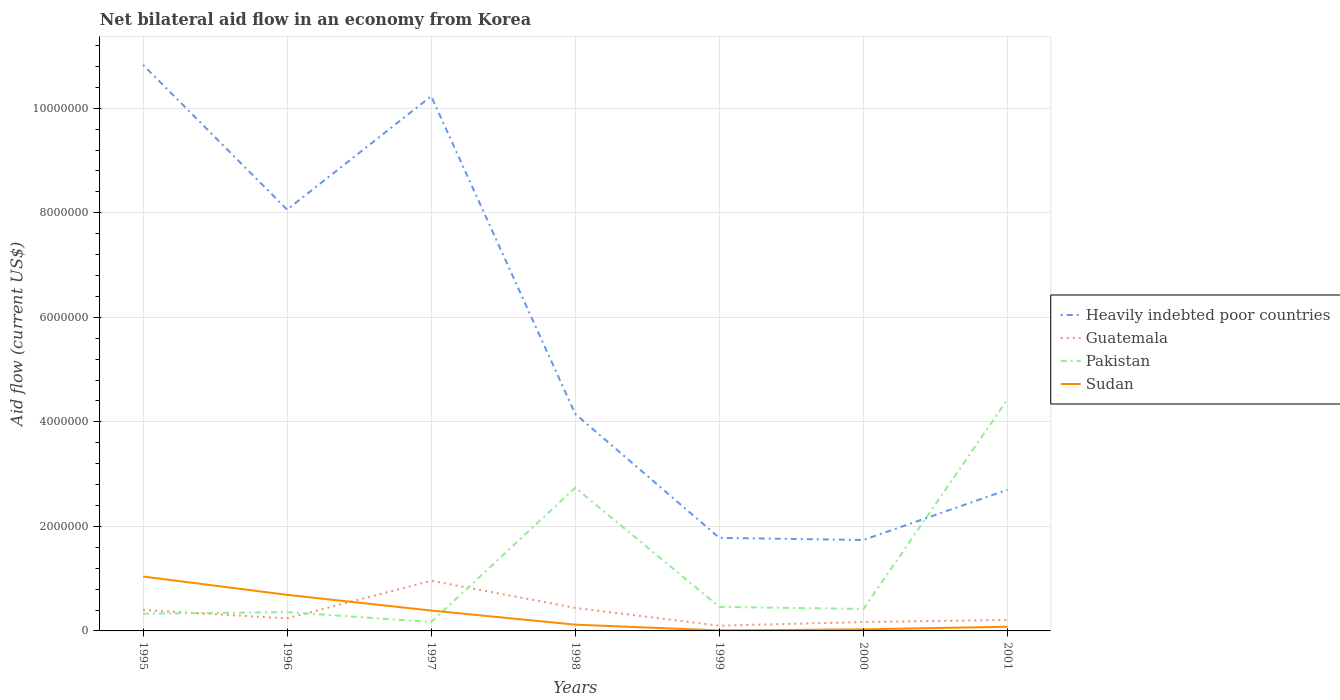How many different coloured lines are there?
Give a very brief answer. 4. Does the line corresponding to Guatemala intersect with the line corresponding to Sudan?
Ensure brevity in your answer.  Yes. What is the total net bilateral aid flow in Sudan in the graph?
Make the answer very short. 6.60e+05. What is the difference between the highest and the second highest net bilateral aid flow in Heavily indebted poor countries?
Your answer should be very brief. 9.09e+06. Is the net bilateral aid flow in Heavily indebted poor countries strictly greater than the net bilateral aid flow in Pakistan over the years?
Provide a short and direct response. No. How many lines are there?
Provide a short and direct response. 4. How many years are there in the graph?
Provide a short and direct response. 7. Are the values on the major ticks of Y-axis written in scientific E-notation?
Your answer should be very brief. No. Does the graph contain any zero values?
Your answer should be very brief. No. Where does the legend appear in the graph?
Your answer should be compact. Center right. How are the legend labels stacked?
Make the answer very short. Vertical. What is the title of the graph?
Keep it short and to the point. Net bilateral aid flow in an economy from Korea. What is the Aid flow (current US$) in Heavily indebted poor countries in 1995?
Ensure brevity in your answer.  1.08e+07. What is the Aid flow (current US$) of Sudan in 1995?
Make the answer very short. 1.04e+06. What is the Aid flow (current US$) in Heavily indebted poor countries in 1996?
Keep it short and to the point. 8.06e+06. What is the Aid flow (current US$) in Guatemala in 1996?
Give a very brief answer. 2.40e+05. What is the Aid flow (current US$) in Sudan in 1996?
Your answer should be very brief. 6.90e+05. What is the Aid flow (current US$) in Heavily indebted poor countries in 1997?
Your answer should be very brief. 1.02e+07. What is the Aid flow (current US$) in Guatemala in 1997?
Your answer should be very brief. 9.60e+05. What is the Aid flow (current US$) in Sudan in 1997?
Your answer should be very brief. 3.90e+05. What is the Aid flow (current US$) in Heavily indebted poor countries in 1998?
Make the answer very short. 4.15e+06. What is the Aid flow (current US$) of Guatemala in 1998?
Make the answer very short. 4.40e+05. What is the Aid flow (current US$) in Pakistan in 1998?
Your answer should be very brief. 2.74e+06. What is the Aid flow (current US$) of Sudan in 1998?
Provide a short and direct response. 1.20e+05. What is the Aid flow (current US$) in Heavily indebted poor countries in 1999?
Your response must be concise. 1.78e+06. What is the Aid flow (current US$) of Guatemala in 1999?
Your response must be concise. 1.00e+05. What is the Aid flow (current US$) of Sudan in 1999?
Your answer should be compact. 10000. What is the Aid flow (current US$) of Heavily indebted poor countries in 2000?
Provide a succinct answer. 1.74e+06. What is the Aid flow (current US$) of Guatemala in 2000?
Your response must be concise. 1.70e+05. What is the Aid flow (current US$) in Pakistan in 2000?
Provide a succinct answer. 4.20e+05. What is the Aid flow (current US$) of Sudan in 2000?
Your answer should be compact. 3.00e+04. What is the Aid flow (current US$) of Heavily indebted poor countries in 2001?
Provide a succinct answer. 2.70e+06. What is the Aid flow (current US$) of Pakistan in 2001?
Provide a short and direct response. 4.43e+06. Across all years, what is the maximum Aid flow (current US$) of Heavily indebted poor countries?
Give a very brief answer. 1.08e+07. Across all years, what is the maximum Aid flow (current US$) of Guatemala?
Your answer should be compact. 9.60e+05. Across all years, what is the maximum Aid flow (current US$) in Pakistan?
Make the answer very short. 4.43e+06. Across all years, what is the maximum Aid flow (current US$) in Sudan?
Ensure brevity in your answer.  1.04e+06. Across all years, what is the minimum Aid flow (current US$) in Heavily indebted poor countries?
Provide a short and direct response. 1.74e+06. Across all years, what is the minimum Aid flow (current US$) of Pakistan?
Your response must be concise. 1.70e+05. Across all years, what is the minimum Aid flow (current US$) in Sudan?
Your answer should be very brief. 10000. What is the total Aid flow (current US$) of Heavily indebted poor countries in the graph?
Give a very brief answer. 3.95e+07. What is the total Aid flow (current US$) of Guatemala in the graph?
Keep it short and to the point. 2.52e+06. What is the total Aid flow (current US$) of Pakistan in the graph?
Your response must be concise. 8.91e+06. What is the total Aid flow (current US$) of Sudan in the graph?
Provide a short and direct response. 2.36e+06. What is the difference between the Aid flow (current US$) in Heavily indebted poor countries in 1995 and that in 1996?
Provide a succinct answer. 2.77e+06. What is the difference between the Aid flow (current US$) of Guatemala in 1995 and that in 1996?
Offer a terse response. 1.60e+05. What is the difference between the Aid flow (current US$) of Pakistan in 1995 and that in 1996?
Keep it short and to the point. -3.00e+04. What is the difference between the Aid flow (current US$) of Guatemala in 1995 and that in 1997?
Provide a short and direct response. -5.60e+05. What is the difference between the Aid flow (current US$) of Pakistan in 1995 and that in 1997?
Your answer should be compact. 1.60e+05. What is the difference between the Aid flow (current US$) of Sudan in 1995 and that in 1997?
Your response must be concise. 6.50e+05. What is the difference between the Aid flow (current US$) in Heavily indebted poor countries in 1995 and that in 1998?
Your answer should be very brief. 6.68e+06. What is the difference between the Aid flow (current US$) in Pakistan in 1995 and that in 1998?
Provide a succinct answer. -2.41e+06. What is the difference between the Aid flow (current US$) of Sudan in 1995 and that in 1998?
Your response must be concise. 9.20e+05. What is the difference between the Aid flow (current US$) in Heavily indebted poor countries in 1995 and that in 1999?
Offer a very short reply. 9.05e+06. What is the difference between the Aid flow (current US$) of Guatemala in 1995 and that in 1999?
Give a very brief answer. 3.00e+05. What is the difference between the Aid flow (current US$) of Sudan in 1995 and that in 1999?
Your response must be concise. 1.03e+06. What is the difference between the Aid flow (current US$) of Heavily indebted poor countries in 1995 and that in 2000?
Your answer should be very brief. 9.09e+06. What is the difference between the Aid flow (current US$) in Guatemala in 1995 and that in 2000?
Your answer should be very brief. 2.30e+05. What is the difference between the Aid flow (current US$) in Sudan in 1995 and that in 2000?
Ensure brevity in your answer.  1.01e+06. What is the difference between the Aid flow (current US$) in Heavily indebted poor countries in 1995 and that in 2001?
Your response must be concise. 8.13e+06. What is the difference between the Aid flow (current US$) in Pakistan in 1995 and that in 2001?
Keep it short and to the point. -4.10e+06. What is the difference between the Aid flow (current US$) of Sudan in 1995 and that in 2001?
Your response must be concise. 9.60e+05. What is the difference between the Aid flow (current US$) in Heavily indebted poor countries in 1996 and that in 1997?
Your answer should be compact. -2.17e+06. What is the difference between the Aid flow (current US$) of Guatemala in 1996 and that in 1997?
Provide a short and direct response. -7.20e+05. What is the difference between the Aid flow (current US$) in Pakistan in 1996 and that in 1997?
Keep it short and to the point. 1.90e+05. What is the difference between the Aid flow (current US$) of Sudan in 1996 and that in 1997?
Your answer should be very brief. 3.00e+05. What is the difference between the Aid flow (current US$) of Heavily indebted poor countries in 1996 and that in 1998?
Give a very brief answer. 3.91e+06. What is the difference between the Aid flow (current US$) in Guatemala in 1996 and that in 1998?
Your answer should be compact. -2.00e+05. What is the difference between the Aid flow (current US$) in Pakistan in 1996 and that in 1998?
Provide a short and direct response. -2.38e+06. What is the difference between the Aid flow (current US$) of Sudan in 1996 and that in 1998?
Make the answer very short. 5.70e+05. What is the difference between the Aid flow (current US$) of Heavily indebted poor countries in 1996 and that in 1999?
Make the answer very short. 6.28e+06. What is the difference between the Aid flow (current US$) in Guatemala in 1996 and that in 1999?
Keep it short and to the point. 1.40e+05. What is the difference between the Aid flow (current US$) of Pakistan in 1996 and that in 1999?
Your response must be concise. -1.00e+05. What is the difference between the Aid flow (current US$) in Sudan in 1996 and that in 1999?
Your answer should be very brief. 6.80e+05. What is the difference between the Aid flow (current US$) of Heavily indebted poor countries in 1996 and that in 2000?
Your response must be concise. 6.32e+06. What is the difference between the Aid flow (current US$) in Sudan in 1996 and that in 2000?
Provide a succinct answer. 6.60e+05. What is the difference between the Aid flow (current US$) of Heavily indebted poor countries in 1996 and that in 2001?
Provide a short and direct response. 5.36e+06. What is the difference between the Aid flow (current US$) of Pakistan in 1996 and that in 2001?
Offer a terse response. -4.07e+06. What is the difference between the Aid flow (current US$) of Sudan in 1996 and that in 2001?
Keep it short and to the point. 6.10e+05. What is the difference between the Aid flow (current US$) of Heavily indebted poor countries in 1997 and that in 1998?
Provide a short and direct response. 6.08e+06. What is the difference between the Aid flow (current US$) of Guatemala in 1997 and that in 1998?
Provide a succinct answer. 5.20e+05. What is the difference between the Aid flow (current US$) of Pakistan in 1997 and that in 1998?
Keep it short and to the point. -2.57e+06. What is the difference between the Aid flow (current US$) in Heavily indebted poor countries in 1997 and that in 1999?
Keep it short and to the point. 8.45e+06. What is the difference between the Aid flow (current US$) in Guatemala in 1997 and that in 1999?
Give a very brief answer. 8.60e+05. What is the difference between the Aid flow (current US$) in Sudan in 1997 and that in 1999?
Provide a short and direct response. 3.80e+05. What is the difference between the Aid flow (current US$) of Heavily indebted poor countries in 1997 and that in 2000?
Your response must be concise. 8.49e+06. What is the difference between the Aid flow (current US$) of Guatemala in 1997 and that in 2000?
Keep it short and to the point. 7.90e+05. What is the difference between the Aid flow (current US$) in Pakistan in 1997 and that in 2000?
Provide a short and direct response. -2.50e+05. What is the difference between the Aid flow (current US$) of Heavily indebted poor countries in 1997 and that in 2001?
Your response must be concise. 7.53e+06. What is the difference between the Aid flow (current US$) in Guatemala in 1997 and that in 2001?
Provide a short and direct response. 7.50e+05. What is the difference between the Aid flow (current US$) of Pakistan in 1997 and that in 2001?
Offer a terse response. -4.26e+06. What is the difference between the Aid flow (current US$) of Sudan in 1997 and that in 2001?
Your answer should be compact. 3.10e+05. What is the difference between the Aid flow (current US$) of Heavily indebted poor countries in 1998 and that in 1999?
Offer a terse response. 2.37e+06. What is the difference between the Aid flow (current US$) in Pakistan in 1998 and that in 1999?
Offer a terse response. 2.28e+06. What is the difference between the Aid flow (current US$) of Sudan in 1998 and that in 1999?
Offer a very short reply. 1.10e+05. What is the difference between the Aid flow (current US$) in Heavily indebted poor countries in 1998 and that in 2000?
Provide a succinct answer. 2.41e+06. What is the difference between the Aid flow (current US$) of Pakistan in 1998 and that in 2000?
Give a very brief answer. 2.32e+06. What is the difference between the Aid flow (current US$) in Sudan in 1998 and that in 2000?
Keep it short and to the point. 9.00e+04. What is the difference between the Aid flow (current US$) in Heavily indebted poor countries in 1998 and that in 2001?
Provide a succinct answer. 1.45e+06. What is the difference between the Aid flow (current US$) of Pakistan in 1998 and that in 2001?
Offer a very short reply. -1.69e+06. What is the difference between the Aid flow (current US$) in Heavily indebted poor countries in 1999 and that in 2000?
Give a very brief answer. 4.00e+04. What is the difference between the Aid flow (current US$) of Heavily indebted poor countries in 1999 and that in 2001?
Provide a succinct answer. -9.20e+05. What is the difference between the Aid flow (current US$) in Pakistan in 1999 and that in 2001?
Provide a short and direct response. -3.97e+06. What is the difference between the Aid flow (current US$) in Sudan in 1999 and that in 2001?
Your response must be concise. -7.00e+04. What is the difference between the Aid flow (current US$) in Heavily indebted poor countries in 2000 and that in 2001?
Make the answer very short. -9.60e+05. What is the difference between the Aid flow (current US$) in Guatemala in 2000 and that in 2001?
Your answer should be very brief. -4.00e+04. What is the difference between the Aid flow (current US$) of Pakistan in 2000 and that in 2001?
Provide a succinct answer. -4.01e+06. What is the difference between the Aid flow (current US$) of Sudan in 2000 and that in 2001?
Ensure brevity in your answer.  -5.00e+04. What is the difference between the Aid flow (current US$) of Heavily indebted poor countries in 1995 and the Aid flow (current US$) of Guatemala in 1996?
Ensure brevity in your answer.  1.06e+07. What is the difference between the Aid flow (current US$) of Heavily indebted poor countries in 1995 and the Aid flow (current US$) of Pakistan in 1996?
Provide a succinct answer. 1.05e+07. What is the difference between the Aid flow (current US$) in Heavily indebted poor countries in 1995 and the Aid flow (current US$) in Sudan in 1996?
Keep it short and to the point. 1.01e+07. What is the difference between the Aid flow (current US$) of Guatemala in 1995 and the Aid flow (current US$) of Pakistan in 1996?
Ensure brevity in your answer.  4.00e+04. What is the difference between the Aid flow (current US$) of Pakistan in 1995 and the Aid flow (current US$) of Sudan in 1996?
Provide a short and direct response. -3.60e+05. What is the difference between the Aid flow (current US$) in Heavily indebted poor countries in 1995 and the Aid flow (current US$) in Guatemala in 1997?
Provide a succinct answer. 9.87e+06. What is the difference between the Aid flow (current US$) of Heavily indebted poor countries in 1995 and the Aid flow (current US$) of Pakistan in 1997?
Your response must be concise. 1.07e+07. What is the difference between the Aid flow (current US$) of Heavily indebted poor countries in 1995 and the Aid flow (current US$) of Sudan in 1997?
Offer a very short reply. 1.04e+07. What is the difference between the Aid flow (current US$) in Guatemala in 1995 and the Aid flow (current US$) in Pakistan in 1997?
Your answer should be very brief. 2.30e+05. What is the difference between the Aid flow (current US$) in Pakistan in 1995 and the Aid flow (current US$) in Sudan in 1997?
Your answer should be compact. -6.00e+04. What is the difference between the Aid flow (current US$) of Heavily indebted poor countries in 1995 and the Aid flow (current US$) of Guatemala in 1998?
Your answer should be very brief. 1.04e+07. What is the difference between the Aid flow (current US$) of Heavily indebted poor countries in 1995 and the Aid flow (current US$) of Pakistan in 1998?
Provide a succinct answer. 8.09e+06. What is the difference between the Aid flow (current US$) of Heavily indebted poor countries in 1995 and the Aid flow (current US$) of Sudan in 1998?
Offer a very short reply. 1.07e+07. What is the difference between the Aid flow (current US$) in Guatemala in 1995 and the Aid flow (current US$) in Pakistan in 1998?
Make the answer very short. -2.34e+06. What is the difference between the Aid flow (current US$) of Guatemala in 1995 and the Aid flow (current US$) of Sudan in 1998?
Your response must be concise. 2.80e+05. What is the difference between the Aid flow (current US$) in Heavily indebted poor countries in 1995 and the Aid flow (current US$) in Guatemala in 1999?
Keep it short and to the point. 1.07e+07. What is the difference between the Aid flow (current US$) of Heavily indebted poor countries in 1995 and the Aid flow (current US$) of Pakistan in 1999?
Offer a terse response. 1.04e+07. What is the difference between the Aid flow (current US$) of Heavily indebted poor countries in 1995 and the Aid flow (current US$) of Sudan in 1999?
Your response must be concise. 1.08e+07. What is the difference between the Aid flow (current US$) in Guatemala in 1995 and the Aid flow (current US$) in Pakistan in 1999?
Your answer should be compact. -6.00e+04. What is the difference between the Aid flow (current US$) in Guatemala in 1995 and the Aid flow (current US$) in Sudan in 1999?
Ensure brevity in your answer.  3.90e+05. What is the difference between the Aid flow (current US$) of Heavily indebted poor countries in 1995 and the Aid flow (current US$) of Guatemala in 2000?
Ensure brevity in your answer.  1.07e+07. What is the difference between the Aid flow (current US$) of Heavily indebted poor countries in 1995 and the Aid flow (current US$) of Pakistan in 2000?
Provide a short and direct response. 1.04e+07. What is the difference between the Aid flow (current US$) of Heavily indebted poor countries in 1995 and the Aid flow (current US$) of Sudan in 2000?
Your answer should be compact. 1.08e+07. What is the difference between the Aid flow (current US$) in Guatemala in 1995 and the Aid flow (current US$) in Sudan in 2000?
Provide a short and direct response. 3.70e+05. What is the difference between the Aid flow (current US$) of Pakistan in 1995 and the Aid flow (current US$) of Sudan in 2000?
Make the answer very short. 3.00e+05. What is the difference between the Aid flow (current US$) in Heavily indebted poor countries in 1995 and the Aid flow (current US$) in Guatemala in 2001?
Offer a very short reply. 1.06e+07. What is the difference between the Aid flow (current US$) in Heavily indebted poor countries in 1995 and the Aid flow (current US$) in Pakistan in 2001?
Offer a very short reply. 6.40e+06. What is the difference between the Aid flow (current US$) of Heavily indebted poor countries in 1995 and the Aid flow (current US$) of Sudan in 2001?
Make the answer very short. 1.08e+07. What is the difference between the Aid flow (current US$) in Guatemala in 1995 and the Aid flow (current US$) in Pakistan in 2001?
Provide a succinct answer. -4.03e+06. What is the difference between the Aid flow (current US$) of Guatemala in 1995 and the Aid flow (current US$) of Sudan in 2001?
Your answer should be compact. 3.20e+05. What is the difference between the Aid flow (current US$) of Heavily indebted poor countries in 1996 and the Aid flow (current US$) of Guatemala in 1997?
Make the answer very short. 7.10e+06. What is the difference between the Aid flow (current US$) in Heavily indebted poor countries in 1996 and the Aid flow (current US$) in Pakistan in 1997?
Your answer should be compact. 7.89e+06. What is the difference between the Aid flow (current US$) of Heavily indebted poor countries in 1996 and the Aid flow (current US$) of Sudan in 1997?
Offer a very short reply. 7.67e+06. What is the difference between the Aid flow (current US$) in Pakistan in 1996 and the Aid flow (current US$) in Sudan in 1997?
Give a very brief answer. -3.00e+04. What is the difference between the Aid flow (current US$) in Heavily indebted poor countries in 1996 and the Aid flow (current US$) in Guatemala in 1998?
Provide a short and direct response. 7.62e+06. What is the difference between the Aid flow (current US$) of Heavily indebted poor countries in 1996 and the Aid flow (current US$) of Pakistan in 1998?
Your answer should be compact. 5.32e+06. What is the difference between the Aid flow (current US$) in Heavily indebted poor countries in 1996 and the Aid flow (current US$) in Sudan in 1998?
Offer a very short reply. 7.94e+06. What is the difference between the Aid flow (current US$) of Guatemala in 1996 and the Aid flow (current US$) of Pakistan in 1998?
Keep it short and to the point. -2.50e+06. What is the difference between the Aid flow (current US$) in Guatemala in 1996 and the Aid flow (current US$) in Sudan in 1998?
Offer a very short reply. 1.20e+05. What is the difference between the Aid flow (current US$) of Pakistan in 1996 and the Aid flow (current US$) of Sudan in 1998?
Make the answer very short. 2.40e+05. What is the difference between the Aid flow (current US$) of Heavily indebted poor countries in 1996 and the Aid flow (current US$) of Guatemala in 1999?
Provide a short and direct response. 7.96e+06. What is the difference between the Aid flow (current US$) in Heavily indebted poor countries in 1996 and the Aid flow (current US$) in Pakistan in 1999?
Offer a terse response. 7.60e+06. What is the difference between the Aid flow (current US$) in Heavily indebted poor countries in 1996 and the Aid flow (current US$) in Sudan in 1999?
Your answer should be compact. 8.05e+06. What is the difference between the Aid flow (current US$) in Guatemala in 1996 and the Aid flow (current US$) in Sudan in 1999?
Your answer should be very brief. 2.30e+05. What is the difference between the Aid flow (current US$) in Heavily indebted poor countries in 1996 and the Aid flow (current US$) in Guatemala in 2000?
Give a very brief answer. 7.89e+06. What is the difference between the Aid flow (current US$) of Heavily indebted poor countries in 1996 and the Aid flow (current US$) of Pakistan in 2000?
Your response must be concise. 7.64e+06. What is the difference between the Aid flow (current US$) of Heavily indebted poor countries in 1996 and the Aid flow (current US$) of Sudan in 2000?
Provide a succinct answer. 8.03e+06. What is the difference between the Aid flow (current US$) in Guatemala in 1996 and the Aid flow (current US$) in Pakistan in 2000?
Offer a very short reply. -1.80e+05. What is the difference between the Aid flow (current US$) in Guatemala in 1996 and the Aid flow (current US$) in Sudan in 2000?
Your response must be concise. 2.10e+05. What is the difference between the Aid flow (current US$) of Heavily indebted poor countries in 1996 and the Aid flow (current US$) of Guatemala in 2001?
Offer a very short reply. 7.85e+06. What is the difference between the Aid flow (current US$) of Heavily indebted poor countries in 1996 and the Aid flow (current US$) of Pakistan in 2001?
Your answer should be compact. 3.63e+06. What is the difference between the Aid flow (current US$) in Heavily indebted poor countries in 1996 and the Aid flow (current US$) in Sudan in 2001?
Your answer should be very brief. 7.98e+06. What is the difference between the Aid flow (current US$) of Guatemala in 1996 and the Aid flow (current US$) of Pakistan in 2001?
Give a very brief answer. -4.19e+06. What is the difference between the Aid flow (current US$) in Heavily indebted poor countries in 1997 and the Aid flow (current US$) in Guatemala in 1998?
Ensure brevity in your answer.  9.79e+06. What is the difference between the Aid flow (current US$) in Heavily indebted poor countries in 1997 and the Aid flow (current US$) in Pakistan in 1998?
Provide a succinct answer. 7.49e+06. What is the difference between the Aid flow (current US$) in Heavily indebted poor countries in 1997 and the Aid flow (current US$) in Sudan in 1998?
Provide a short and direct response. 1.01e+07. What is the difference between the Aid flow (current US$) of Guatemala in 1997 and the Aid flow (current US$) of Pakistan in 1998?
Your response must be concise. -1.78e+06. What is the difference between the Aid flow (current US$) of Guatemala in 1997 and the Aid flow (current US$) of Sudan in 1998?
Give a very brief answer. 8.40e+05. What is the difference between the Aid flow (current US$) in Pakistan in 1997 and the Aid flow (current US$) in Sudan in 1998?
Provide a succinct answer. 5.00e+04. What is the difference between the Aid flow (current US$) in Heavily indebted poor countries in 1997 and the Aid flow (current US$) in Guatemala in 1999?
Offer a very short reply. 1.01e+07. What is the difference between the Aid flow (current US$) in Heavily indebted poor countries in 1997 and the Aid flow (current US$) in Pakistan in 1999?
Your response must be concise. 9.77e+06. What is the difference between the Aid flow (current US$) of Heavily indebted poor countries in 1997 and the Aid flow (current US$) of Sudan in 1999?
Your response must be concise. 1.02e+07. What is the difference between the Aid flow (current US$) in Guatemala in 1997 and the Aid flow (current US$) in Sudan in 1999?
Your answer should be very brief. 9.50e+05. What is the difference between the Aid flow (current US$) in Heavily indebted poor countries in 1997 and the Aid flow (current US$) in Guatemala in 2000?
Offer a very short reply. 1.01e+07. What is the difference between the Aid flow (current US$) in Heavily indebted poor countries in 1997 and the Aid flow (current US$) in Pakistan in 2000?
Your answer should be very brief. 9.81e+06. What is the difference between the Aid flow (current US$) in Heavily indebted poor countries in 1997 and the Aid flow (current US$) in Sudan in 2000?
Your response must be concise. 1.02e+07. What is the difference between the Aid flow (current US$) of Guatemala in 1997 and the Aid flow (current US$) of Pakistan in 2000?
Provide a succinct answer. 5.40e+05. What is the difference between the Aid flow (current US$) of Guatemala in 1997 and the Aid flow (current US$) of Sudan in 2000?
Ensure brevity in your answer.  9.30e+05. What is the difference between the Aid flow (current US$) of Heavily indebted poor countries in 1997 and the Aid flow (current US$) of Guatemala in 2001?
Give a very brief answer. 1.00e+07. What is the difference between the Aid flow (current US$) in Heavily indebted poor countries in 1997 and the Aid flow (current US$) in Pakistan in 2001?
Provide a short and direct response. 5.80e+06. What is the difference between the Aid flow (current US$) in Heavily indebted poor countries in 1997 and the Aid flow (current US$) in Sudan in 2001?
Keep it short and to the point. 1.02e+07. What is the difference between the Aid flow (current US$) in Guatemala in 1997 and the Aid flow (current US$) in Pakistan in 2001?
Your answer should be very brief. -3.47e+06. What is the difference between the Aid flow (current US$) in Guatemala in 1997 and the Aid flow (current US$) in Sudan in 2001?
Make the answer very short. 8.80e+05. What is the difference between the Aid flow (current US$) of Pakistan in 1997 and the Aid flow (current US$) of Sudan in 2001?
Your answer should be compact. 9.00e+04. What is the difference between the Aid flow (current US$) in Heavily indebted poor countries in 1998 and the Aid flow (current US$) in Guatemala in 1999?
Your answer should be compact. 4.05e+06. What is the difference between the Aid flow (current US$) in Heavily indebted poor countries in 1998 and the Aid flow (current US$) in Pakistan in 1999?
Offer a terse response. 3.69e+06. What is the difference between the Aid flow (current US$) in Heavily indebted poor countries in 1998 and the Aid flow (current US$) in Sudan in 1999?
Give a very brief answer. 4.14e+06. What is the difference between the Aid flow (current US$) of Guatemala in 1998 and the Aid flow (current US$) of Pakistan in 1999?
Keep it short and to the point. -2.00e+04. What is the difference between the Aid flow (current US$) of Pakistan in 1998 and the Aid flow (current US$) of Sudan in 1999?
Give a very brief answer. 2.73e+06. What is the difference between the Aid flow (current US$) in Heavily indebted poor countries in 1998 and the Aid flow (current US$) in Guatemala in 2000?
Make the answer very short. 3.98e+06. What is the difference between the Aid flow (current US$) of Heavily indebted poor countries in 1998 and the Aid flow (current US$) of Pakistan in 2000?
Give a very brief answer. 3.73e+06. What is the difference between the Aid flow (current US$) in Heavily indebted poor countries in 1998 and the Aid flow (current US$) in Sudan in 2000?
Provide a short and direct response. 4.12e+06. What is the difference between the Aid flow (current US$) of Guatemala in 1998 and the Aid flow (current US$) of Pakistan in 2000?
Offer a terse response. 2.00e+04. What is the difference between the Aid flow (current US$) of Guatemala in 1998 and the Aid flow (current US$) of Sudan in 2000?
Your response must be concise. 4.10e+05. What is the difference between the Aid flow (current US$) in Pakistan in 1998 and the Aid flow (current US$) in Sudan in 2000?
Provide a succinct answer. 2.71e+06. What is the difference between the Aid flow (current US$) in Heavily indebted poor countries in 1998 and the Aid flow (current US$) in Guatemala in 2001?
Ensure brevity in your answer.  3.94e+06. What is the difference between the Aid flow (current US$) of Heavily indebted poor countries in 1998 and the Aid flow (current US$) of Pakistan in 2001?
Ensure brevity in your answer.  -2.80e+05. What is the difference between the Aid flow (current US$) in Heavily indebted poor countries in 1998 and the Aid flow (current US$) in Sudan in 2001?
Offer a very short reply. 4.07e+06. What is the difference between the Aid flow (current US$) of Guatemala in 1998 and the Aid flow (current US$) of Pakistan in 2001?
Ensure brevity in your answer.  -3.99e+06. What is the difference between the Aid flow (current US$) of Guatemala in 1998 and the Aid flow (current US$) of Sudan in 2001?
Keep it short and to the point. 3.60e+05. What is the difference between the Aid flow (current US$) in Pakistan in 1998 and the Aid flow (current US$) in Sudan in 2001?
Offer a terse response. 2.66e+06. What is the difference between the Aid flow (current US$) in Heavily indebted poor countries in 1999 and the Aid flow (current US$) in Guatemala in 2000?
Ensure brevity in your answer.  1.61e+06. What is the difference between the Aid flow (current US$) of Heavily indebted poor countries in 1999 and the Aid flow (current US$) of Pakistan in 2000?
Keep it short and to the point. 1.36e+06. What is the difference between the Aid flow (current US$) of Heavily indebted poor countries in 1999 and the Aid flow (current US$) of Sudan in 2000?
Offer a terse response. 1.75e+06. What is the difference between the Aid flow (current US$) of Guatemala in 1999 and the Aid flow (current US$) of Pakistan in 2000?
Make the answer very short. -3.20e+05. What is the difference between the Aid flow (current US$) in Heavily indebted poor countries in 1999 and the Aid flow (current US$) in Guatemala in 2001?
Ensure brevity in your answer.  1.57e+06. What is the difference between the Aid flow (current US$) of Heavily indebted poor countries in 1999 and the Aid flow (current US$) of Pakistan in 2001?
Keep it short and to the point. -2.65e+06. What is the difference between the Aid flow (current US$) of Heavily indebted poor countries in 1999 and the Aid flow (current US$) of Sudan in 2001?
Make the answer very short. 1.70e+06. What is the difference between the Aid flow (current US$) in Guatemala in 1999 and the Aid flow (current US$) in Pakistan in 2001?
Give a very brief answer. -4.33e+06. What is the difference between the Aid flow (current US$) in Pakistan in 1999 and the Aid flow (current US$) in Sudan in 2001?
Provide a short and direct response. 3.80e+05. What is the difference between the Aid flow (current US$) of Heavily indebted poor countries in 2000 and the Aid flow (current US$) of Guatemala in 2001?
Offer a very short reply. 1.53e+06. What is the difference between the Aid flow (current US$) of Heavily indebted poor countries in 2000 and the Aid flow (current US$) of Pakistan in 2001?
Ensure brevity in your answer.  -2.69e+06. What is the difference between the Aid flow (current US$) of Heavily indebted poor countries in 2000 and the Aid flow (current US$) of Sudan in 2001?
Your answer should be compact. 1.66e+06. What is the difference between the Aid flow (current US$) in Guatemala in 2000 and the Aid flow (current US$) in Pakistan in 2001?
Your answer should be compact. -4.26e+06. What is the difference between the Aid flow (current US$) in Guatemala in 2000 and the Aid flow (current US$) in Sudan in 2001?
Offer a very short reply. 9.00e+04. What is the difference between the Aid flow (current US$) in Pakistan in 2000 and the Aid flow (current US$) in Sudan in 2001?
Offer a very short reply. 3.40e+05. What is the average Aid flow (current US$) of Heavily indebted poor countries per year?
Provide a succinct answer. 5.64e+06. What is the average Aid flow (current US$) in Guatemala per year?
Your response must be concise. 3.60e+05. What is the average Aid flow (current US$) of Pakistan per year?
Offer a very short reply. 1.27e+06. What is the average Aid flow (current US$) of Sudan per year?
Keep it short and to the point. 3.37e+05. In the year 1995, what is the difference between the Aid flow (current US$) of Heavily indebted poor countries and Aid flow (current US$) of Guatemala?
Ensure brevity in your answer.  1.04e+07. In the year 1995, what is the difference between the Aid flow (current US$) of Heavily indebted poor countries and Aid flow (current US$) of Pakistan?
Your answer should be compact. 1.05e+07. In the year 1995, what is the difference between the Aid flow (current US$) of Heavily indebted poor countries and Aid flow (current US$) of Sudan?
Offer a very short reply. 9.79e+06. In the year 1995, what is the difference between the Aid flow (current US$) in Guatemala and Aid flow (current US$) in Pakistan?
Your answer should be compact. 7.00e+04. In the year 1995, what is the difference between the Aid flow (current US$) in Guatemala and Aid flow (current US$) in Sudan?
Offer a terse response. -6.40e+05. In the year 1995, what is the difference between the Aid flow (current US$) in Pakistan and Aid flow (current US$) in Sudan?
Your response must be concise. -7.10e+05. In the year 1996, what is the difference between the Aid flow (current US$) in Heavily indebted poor countries and Aid flow (current US$) in Guatemala?
Offer a terse response. 7.82e+06. In the year 1996, what is the difference between the Aid flow (current US$) in Heavily indebted poor countries and Aid flow (current US$) in Pakistan?
Keep it short and to the point. 7.70e+06. In the year 1996, what is the difference between the Aid flow (current US$) in Heavily indebted poor countries and Aid flow (current US$) in Sudan?
Your response must be concise. 7.37e+06. In the year 1996, what is the difference between the Aid flow (current US$) of Guatemala and Aid flow (current US$) of Pakistan?
Make the answer very short. -1.20e+05. In the year 1996, what is the difference between the Aid flow (current US$) in Guatemala and Aid flow (current US$) in Sudan?
Provide a short and direct response. -4.50e+05. In the year 1996, what is the difference between the Aid flow (current US$) in Pakistan and Aid flow (current US$) in Sudan?
Make the answer very short. -3.30e+05. In the year 1997, what is the difference between the Aid flow (current US$) in Heavily indebted poor countries and Aid flow (current US$) in Guatemala?
Your answer should be very brief. 9.27e+06. In the year 1997, what is the difference between the Aid flow (current US$) of Heavily indebted poor countries and Aid flow (current US$) of Pakistan?
Provide a short and direct response. 1.01e+07. In the year 1997, what is the difference between the Aid flow (current US$) of Heavily indebted poor countries and Aid flow (current US$) of Sudan?
Keep it short and to the point. 9.84e+06. In the year 1997, what is the difference between the Aid flow (current US$) in Guatemala and Aid flow (current US$) in Pakistan?
Provide a succinct answer. 7.90e+05. In the year 1997, what is the difference between the Aid flow (current US$) of Guatemala and Aid flow (current US$) of Sudan?
Provide a succinct answer. 5.70e+05. In the year 1997, what is the difference between the Aid flow (current US$) in Pakistan and Aid flow (current US$) in Sudan?
Offer a very short reply. -2.20e+05. In the year 1998, what is the difference between the Aid flow (current US$) in Heavily indebted poor countries and Aid flow (current US$) in Guatemala?
Offer a very short reply. 3.71e+06. In the year 1998, what is the difference between the Aid flow (current US$) in Heavily indebted poor countries and Aid flow (current US$) in Pakistan?
Offer a terse response. 1.41e+06. In the year 1998, what is the difference between the Aid flow (current US$) in Heavily indebted poor countries and Aid flow (current US$) in Sudan?
Provide a succinct answer. 4.03e+06. In the year 1998, what is the difference between the Aid flow (current US$) in Guatemala and Aid flow (current US$) in Pakistan?
Your answer should be compact. -2.30e+06. In the year 1998, what is the difference between the Aid flow (current US$) in Pakistan and Aid flow (current US$) in Sudan?
Provide a short and direct response. 2.62e+06. In the year 1999, what is the difference between the Aid flow (current US$) in Heavily indebted poor countries and Aid flow (current US$) in Guatemala?
Offer a very short reply. 1.68e+06. In the year 1999, what is the difference between the Aid flow (current US$) in Heavily indebted poor countries and Aid flow (current US$) in Pakistan?
Give a very brief answer. 1.32e+06. In the year 1999, what is the difference between the Aid flow (current US$) in Heavily indebted poor countries and Aid flow (current US$) in Sudan?
Your answer should be compact. 1.77e+06. In the year 1999, what is the difference between the Aid flow (current US$) of Guatemala and Aid flow (current US$) of Pakistan?
Ensure brevity in your answer.  -3.60e+05. In the year 2000, what is the difference between the Aid flow (current US$) in Heavily indebted poor countries and Aid flow (current US$) in Guatemala?
Your answer should be very brief. 1.57e+06. In the year 2000, what is the difference between the Aid flow (current US$) of Heavily indebted poor countries and Aid flow (current US$) of Pakistan?
Your response must be concise. 1.32e+06. In the year 2000, what is the difference between the Aid flow (current US$) in Heavily indebted poor countries and Aid flow (current US$) in Sudan?
Provide a short and direct response. 1.71e+06. In the year 2000, what is the difference between the Aid flow (current US$) in Guatemala and Aid flow (current US$) in Pakistan?
Your response must be concise. -2.50e+05. In the year 2000, what is the difference between the Aid flow (current US$) of Guatemala and Aid flow (current US$) of Sudan?
Provide a short and direct response. 1.40e+05. In the year 2001, what is the difference between the Aid flow (current US$) in Heavily indebted poor countries and Aid flow (current US$) in Guatemala?
Give a very brief answer. 2.49e+06. In the year 2001, what is the difference between the Aid flow (current US$) of Heavily indebted poor countries and Aid flow (current US$) of Pakistan?
Your answer should be compact. -1.73e+06. In the year 2001, what is the difference between the Aid flow (current US$) in Heavily indebted poor countries and Aid flow (current US$) in Sudan?
Give a very brief answer. 2.62e+06. In the year 2001, what is the difference between the Aid flow (current US$) of Guatemala and Aid flow (current US$) of Pakistan?
Your answer should be very brief. -4.22e+06. In the year 2001, what is the difference between the Aid flow (current US$) in Guatemala and Aid flow (current US$) in Sudan?
Make the answer very short. 1.30e+05. In the year 2001, what is the difference between the Aid flow (current US$) in Pakistan and Aid flow (current US$) in Sudan?
Keep it short and to the point. 4.35e+06. What is the ratio of the Aid flow (current US$) of Heavily indebted poor countries in 1995 to that in 1996?
Your answer should be compact. 1.34. What is the ratio of the Aid flow (current US$) in Sudan in 1995 to that in 1996?
Provide a succinct answer. 1.51. What is the ratio of the Aid flow (current US$) in Heavily indebted poor countries in 1995 to that in 1997?
Your answer should be very brief. 1.06. What is the ratio of the Aid flow (current US$) of Guatemala in 1995 to that in 1997?
Give a very brief answer. 0.42. What is the ratio of the Aid flow (current US$) of Pakistan in 1995 to that in 1997?
Your answer should be compact. 1.94. What is the ratio of the Aid flow (current US$) in Sudan in 1995 to that in 1997?
Your answer should be compact. 2.67. What is the ratio of the Aid flow (current US$) of Heavily indebted poor countries in 1995 to that in 1998?
Keep it short and to the point. 2.61. What is the ratio of the Aid flow (current US$) in Pakistan in 1995 to that in 1998?
Your answer should be compact. 0.12. What is the ratio of the Aid flow (current US$) of Sudan in 1995 to that in 1998?
Keep it short and to the point. 8.67. What is the ratio of the Aid flow (current US$) in Heavily indebted poor countries in 1995 to that in 1999?
Ensure brevity in your answer.  6.08. What is the ratio of the Aid flow (current US$) of Pakistan in 1995 to that in 1999?
Give a very brief answer. 0.72. What is the ratio of the Aid flow (current US$) in Sudan in 1995 to that in 1999?
Your answer should be compact. 104. What is the ratio of the Aid flow (current US$) in Heavily indebted poor countries in 1995 to that in 2000?
Offer a terse response. 6.22. What is the ratio of the Aid flow (current US$) of Guatemala in 1995 to that in 2000?
Provide a short and direct response. 2.35. What is the ratio of the Aid flow (current US$) of Pakistan in 1995 to that in 2000?
Make the answer very short. 0.79. What is the ratio of the Aid flow (current US$) in Sudan in 1995 to that in 2000?
Offer a very short reply. 34.67. What is the ratio of the Aid flow (current US$) of Heavily indebted poor countries in 1995 to that in 2001?
Keep it short and to the point. 4.01. What is the ratio of the Aid flow (current US$) of Guatemala in 1995 to that in 2001?
Your response must be concise. 1.9. What is the ratio of the Aid flow (current US$) in Pakistan in 1995 to that in 2001?
Give a very brief answer. 0.07. What is the ratio of the Aid flow (current US$) in Heavily indebted poor countries in 1996 to that in 1997?
Provide a succinct answer. 0.79. What is the ratio of the Aid flow (current US$) of Pakistan in 1996 to that in 1997?
Your response must be concise. 2.12. What is the ratio of the Aid flow (current US$) of Sudan in 1996 to that in 1997?
Your response must be concise. 1.77. What is the ratio of the Aid flow (current US$) in Heavily indebted poor countries in 1996 to that in 1998?
Offer a terse response. 1.94. What is the ratio of the Aid flow (current US$) of Guatemala in 1996 to that in 1998?
Ensure brevity in your answer.  0.55. What is the ratio of the Aid flow (current US$) of Pakistan in 1996 to that in 1998?
Ensure brevity in your answer.  0.13. What is the ratio of the Aid flow (current US$) of Sudan in 1996 to that in 1998?
Your answer should be very brief. 5.75. What is the ratio of the Aid flow (current US$) of Heavily indebted poor countries in 1996 to that in 1999?
Offer a terse response. 4.53. What is the ratio of the Aid flow (current US$) in Guatemala in 1996 to that in 1999?
Your answer should be very brief. 2.4. What is the ratio of the Aid flow (current US$) of Pakistan in 1996 to that in 1999?
Ensure brevity in your answer.  0.78. What is the ratio of the Aid flow (current US$) in Sudan in 1996 to that in 1999?
Your response must be concise. 69. What is the ratio of the Aid flow (current US$) in Heavily indebted poor countries in 1996 to that in 2000?
Keep it short and to the point. 4.63. What is the ratio of the Aid flow (current US$) in Guatemala in 1996 to that in 2000?
Give a very brief answer. 1.41. What is the ratio of the Aid flow (current US$) in Heavily indebted poor countries in 1996 to that in 2001?
Ensure brevity in your answer.  2.99. What is the ratio of the Aid flow (current US$) of Pakistan in 1996 to that in 2001?
Offer a very short reply. 0.08. What is the ratio of the Aid flow (current US$) of Sudan in 1996 to that in 2001?
Keep it short and to the point. 8.62. What is the ratio of the Aid flow (current US$) of Heavily indebted poor countries in 1997 to that in 1998?
Offer a very short reply. 2.47. What is the ratio of the Aid flow (current US$) in Guatemala in 1997 to that in 1998?
Your response must be concise. 2.18. What is the ratio of the Aid flow (current US$) of Pakistan in 1997 to that in 1998?
Give a very brief answer. 0.06. What is the ratio of the Aid flow (current US$) of Heavily indebted poor countries in 1997 to that in 1999?
Make the answer very short. 5.75. What is the ratio of the Aid flow (current US$) of Pakistan in 1997 to that in 1999?
Make the answer very short. 0.37. What is the ratio of the Aid flow (current US$) in Sudan in 1997 to that in 1999?
Ensure brevity in your answer.  39. What is the ratio of the Aid flow (current US$) of Heavily indebted poor countries in 1997 to that in 2000?
Your answer should be very brief. 5.88. What is the ratio of the Aid flow (current US$) of Guatemala in 1997 to that in 2000?
Provide a succinct answer. 5.65. What is the ratio of the Aid flow (current US$) of Pakistan in 1997 to that in 2000?
Make the answer very short. 0.4. What is the ratio of the Aid flow (current US$) of Heavily indebted poor countries in 1997 to that in 2001?
Provide a succinct answer. 3.79. What is the ratio of the Aid flow (current US$) of Guatemala in 1997 to that in 2001?
Offer a terse response. 4.57. What is the ratio of the Aid flow (current US$) of Pakistan in 1997 to that in 2001?
Your answer should be compact. 0.04. What is the ratio of the Aid flow (current US$) in Sudan in 1997 to that in 2001?
Offer a terse response. 4.88. What is the ratio of the Aid flow (current US$) of Heavily indebted poor countries in 1998 to that in 1999?
Your answer should be compact. 2.33. What is the ratio of the Aid flow (current US$) of Pakistan in 1998 to that in 1999?
Give a very brief answer. 5.96. What is the ratio of the Aid flow (current US$) in Heavily indebted poor countries in 1998 to that in 2000?
Make the answer very short. 2.39. What is the ratio of the Aid flow (current US$) of Guatemala in 1998 to that in 2000?
Make the answer very short. 2.59. What is the ratio of the Aid flow (current US$) of Pakistan in 1998 to that in 2000?
Make the answer very short. 6.52. What is the ratio of the Aid flow (current US$) of Sudan in 1998 to that in 2000?
Give a very brief answer. 4. What is the ratio of the Aid flow (current US$) of Heavily indebted poor countries in 1998 to that in 2001?
Your answer should be compact. 1.54. What is the ratio of the Aid flow (current US$) in Guatemala in 1998 to that in 2001?
Make the answer very short. 2.1. What is the ratio of the Aid flow (current US$) of Pakistan in 1998 to that in 2001?
Give a very brief answer. 0.62. What is the ratio of the Aid flow (current US$) in Guatemala in 1999 to that in 2000?
Make the answer very short. 0.59. What is the ratio of the Aid flow (current US$) of Pakistan in 1999 to that in 2000?
Give a very brief answer. 1.1. What is the ratio of the Aid flow (current US$) of Heavily indebted poor countries in 1999 to that in 2001?
Ensure brevity in your answer.  0.66. What is the ratio of the Aid flow (current US$) in Guatemala in 1999 to that in 2001?
Your answer should be very brief. 0.48. What is the ratio of the Aid flow (current US$) of Pakistan in 1999 to that in 2001?
Offer a terse response. 0.1. What is the ratio of the Aid flow (current US$) in Heavily indebted poor countries in 2000 to that in 2001?
Your answer should be very brief. 0.64. What is the ratio of the Aid flow (current US$) of Guatemala in 2000 to that in 2001?
Ensure brevity in your answer.  0.81. What is the ratio of the Aid flow (current US$) of Pakistan in 2000 to that in 2001?
Offer a terse response. 0.09. What is the difference between the highest and the second highest Aid flow (current US$) of Heavily indebted poor countries?
Offer a terse response. 6.00e+05. What is the difference between the highest and the second highest Aid flow (current US$) of Guatemala?
Provide a short and direct response. 5.20e+05. What is the difference between the highest and the second highest Aid flow (current US$) of Pakistan?
Your answer should be very brief. 1.69e+06. What is the difference between the highest and the lowest Aid flow (current US$) of Heavily indebted poor countries?
Offer a very short reply. 9.09e+06. What is the difference between the highest and the lowest Aid flow (current US$) in Guatemala?
Give a very brief answer. 8.60e+05. What is the difference between the highest and the lowest Aid flow (current US$) of Pakistan?
Offer a very short reply. 4.26e+06. What is the difference between the highest and the lowest Aid flow (current US$) in Sudan?
Ensure brevity in your answer.  1.03e+06. 